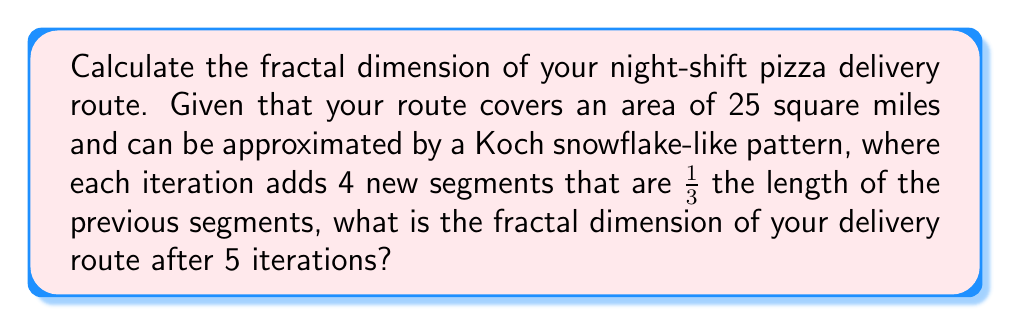What is the answer to this math problem? To calculate the fractal dimension of the pizza delivery route, we'll use the box-counting method. The fractal dimension $D$ is given by the formula:

$$D = \frac{\log N}{\log (1/r)}$$

Where:
$N$ = number of self-similar pieces
$r$ = scaling factor

For a Koch snowflake-like pattern:
1. In each iteration, each segment is divided into 4 new segments.
2. The scaling factor is 1/3.

After 5 iterations:
1. Number of segments: $N = 4^5 = 1024$
2. Scaling factor: $r = (1/3)^5 = 1/243$

Plugging these values into the formula:

$$D = \frac{\log 1024}{\log 243}$$

$$D = \frac{\log 2^{10}}{\log 3^5}$$

$$D = \frac{10 \log 2}{5 \log 3}$$

$$D = \frac{10 \times 0.30103}{5 \times 0.47712}$$

$$D = \frac{3.0103}{2.3856}$$

$$D \approx 1.2618$$

This fractal dimension lies between 1 (a line) and 2 (a plane), indicating a complex, space-filling curve that represents the intricate pizza delivery route.
Answer: $D \approx 1.2618$ 